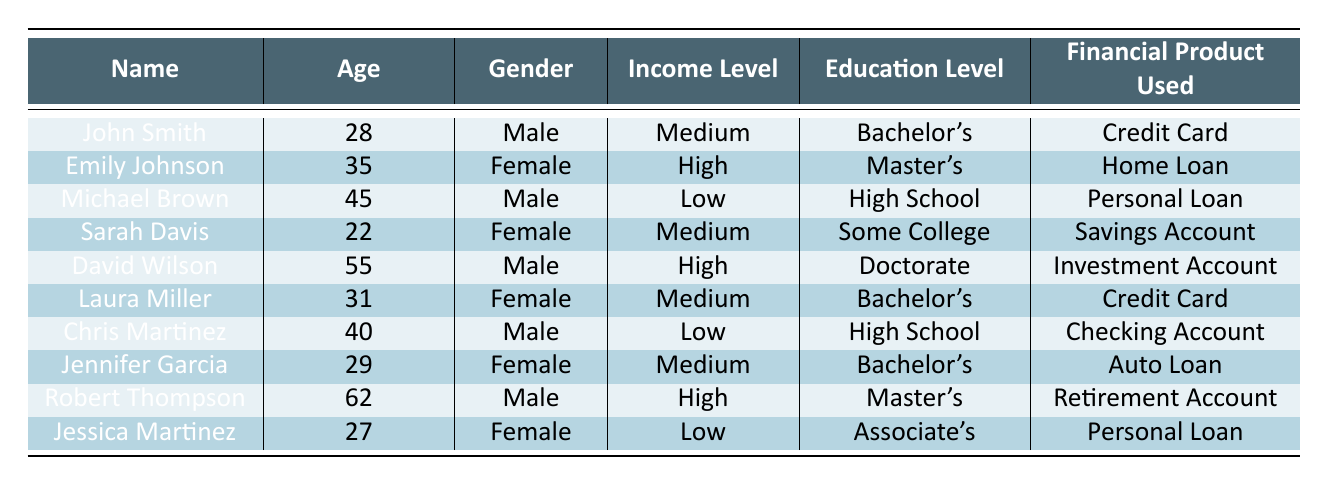What is the financial product used by David Wilson? You can find David Wilson’s entry in the table listed under the "Name" column. Looking to the right under "Financial Product Used," we see that he uses an "Investment Account."
Answer: Investment Account How many females attended the workshop? By counting the rows for female attendees in the "Gender" column, we find that there are 5 females: Emily Johnson, Sarah Davis, Laura Miller, Jennifer Garcia, and Jessica Martinez.
Answer: 5 What is the average age of attendees who use a Credit Card? We identify the attendees using a Credit Card: John Smith (28) and Laura Miller (31). To calculate the average age, we sum these ages: 28 + 31 = 59. There are 2 attendees, so the average age is 59/2 = 29.5.
Answer: 29.5 Did any attendees with a Low income level use a Home Loan? In the "Income Level" column, we look for "Low" and check the corresponding "Financial Product Used." Michael Brown (Personal Loan), Chris Martinez (Checking Account), and Jessica Martinez (Personal Loan) are the attendees with Low income, but none of them use a Home Loan.
Answer: No Which financial products are used by attendees aged over 40? Checking the ages in the "Age" column, we find David Wilson (55) uses an Investment Account, Robert Thompson (62) uses a Retirement Account, and Michael Brown (45) uses a Personal Loan. The unique financial products used are Investment Account, Retirement Account, and Personal Loan.
Answer: Investment Account, Retirement Account, Personal Loan How many attendees have a Doctorate education level? Looking at the "Education Level" column, we see that there is only one attendee, David Wilson, listed with a Doctorate degree.
Answer: 1 Are there any attendees using a Savings Account who have a Medium income level? By checking the "Financial Product Used" for the "Medium" category in the "Income Level" column, we see Sarah Davis who uses a Savings Account fits this criteria.
Answer: Yes What is the most common financial product used by attendees with a Bachelor’s degree? There are three attendees with a Bachelor’s degree: John Smith and Laura Miller (both use Credit Cards) and Jennifer Garcia (uses an Auto Loan). Counting the occurrences: 2 use Credit Cards, 1 uses an Auto Loan. Therefore, Credit Card is the most common product used.
Answer: Credit Card 